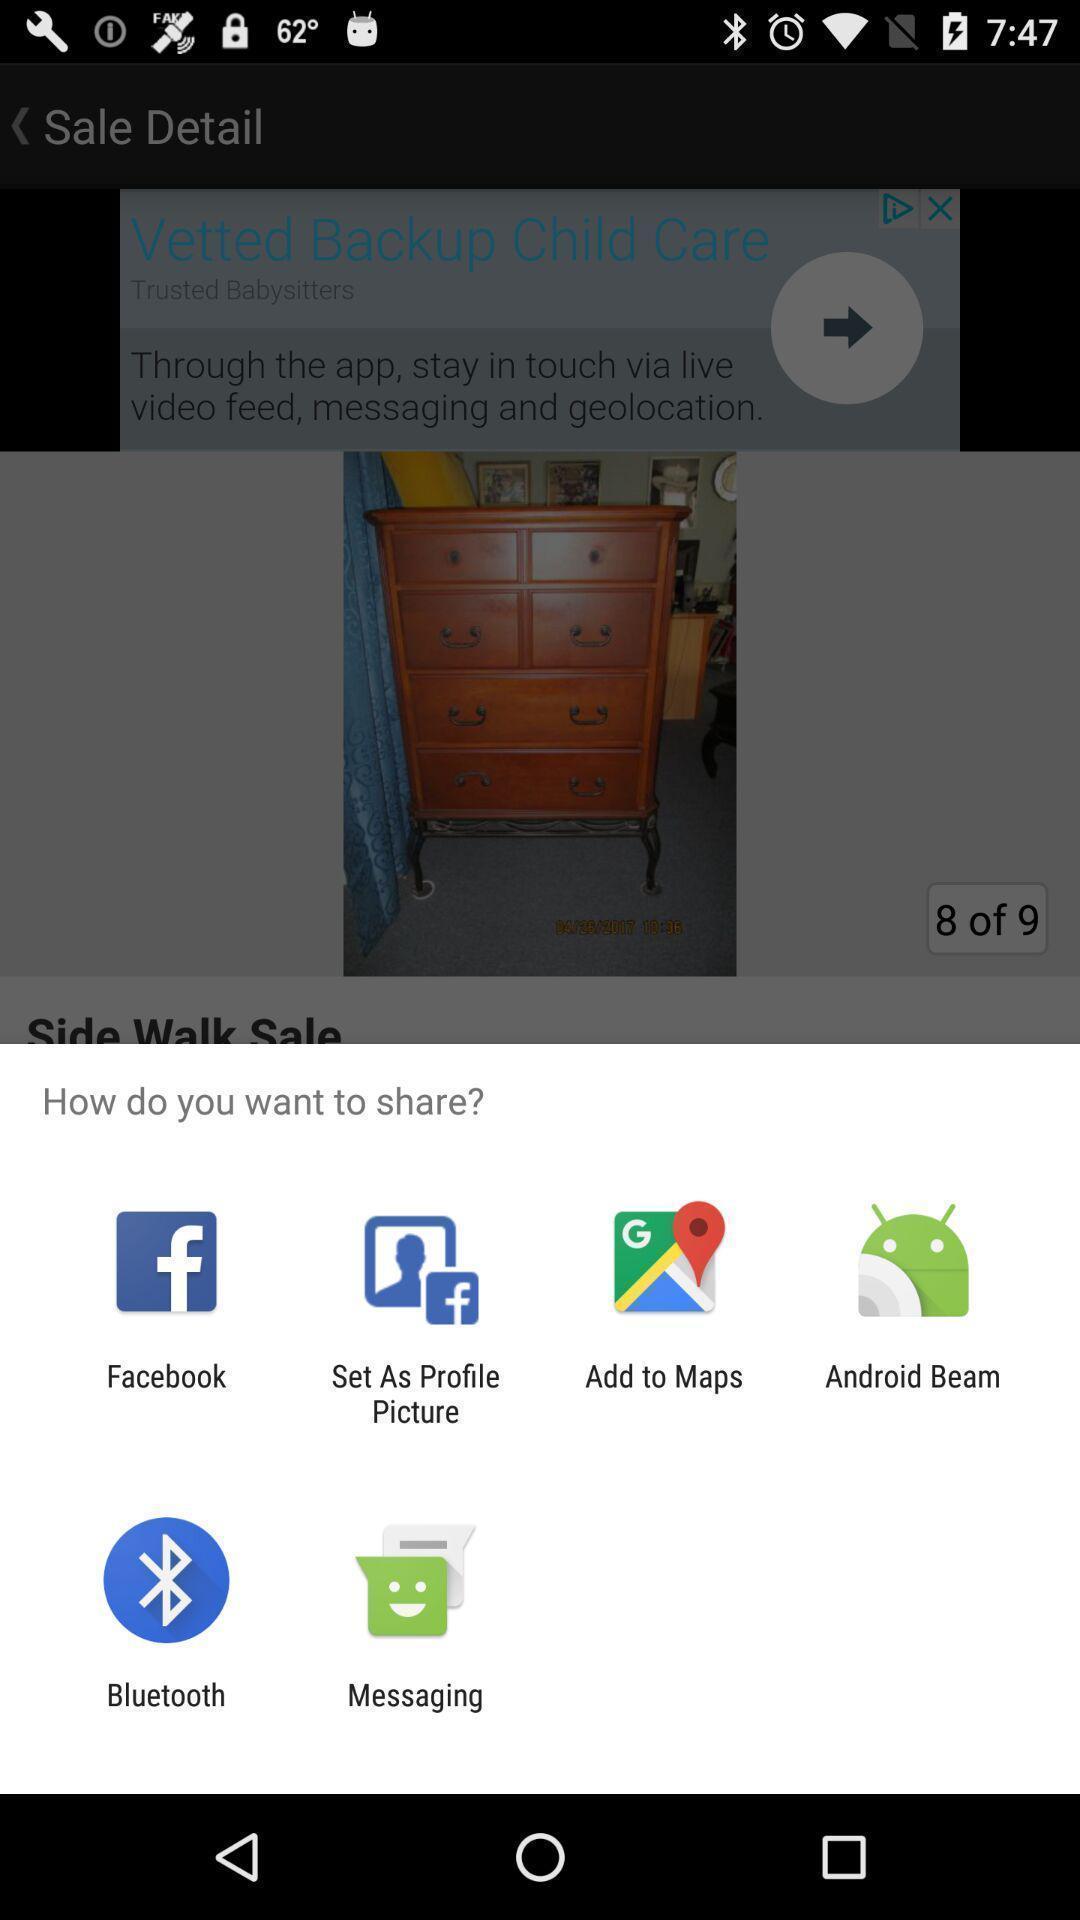What is the overall content of this screenshot? Popup showing different apps to share. 